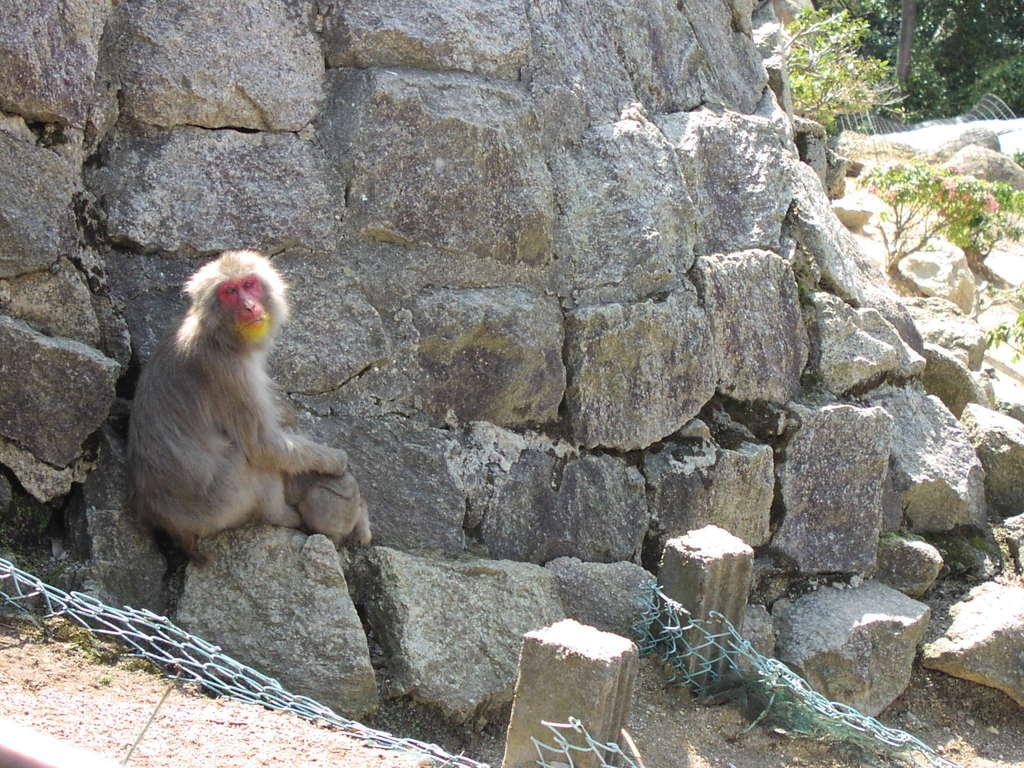What type of natural formation can be seen in the image? There are rocks in the image. What is the monkey doing in the image? A monkey is sitting on a rock in the image. What is the color of the net fencing in the image? The net fencing in the image is green-colored. What type of vegetation is visible in the background of the image? There are trees in the background of the image. What is the color of the trees in the image? The trees in the image are green in color. Reasoning: Let's think step by step by following the steps to produce the conversation. We start by identifying the main subjects and objects in the image based on the provided facts. We then formulate questions that focus on the location and characteristics of these subjects and objects, ensuring that each question can be answered definitively with the information given. We avoid yes/no questions and ensure that the language is simple and clear. Absurd Question/Answer: Can you see a bear holding a rose in the image? No, there is no bear or rose present in the image. What type of facial expression does the monkey have in the image? The image does not show the monkey's face, so it is not possible to determine its facial expression. 